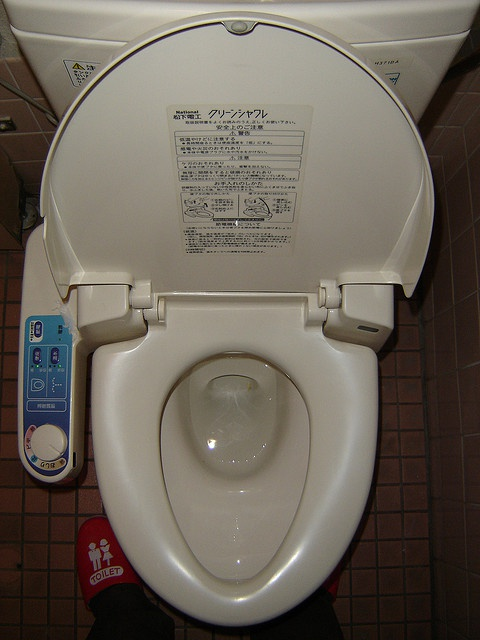Describe the objects in this image and their specific colors. I can see a toilet in gray and darkgray tones in this image. 